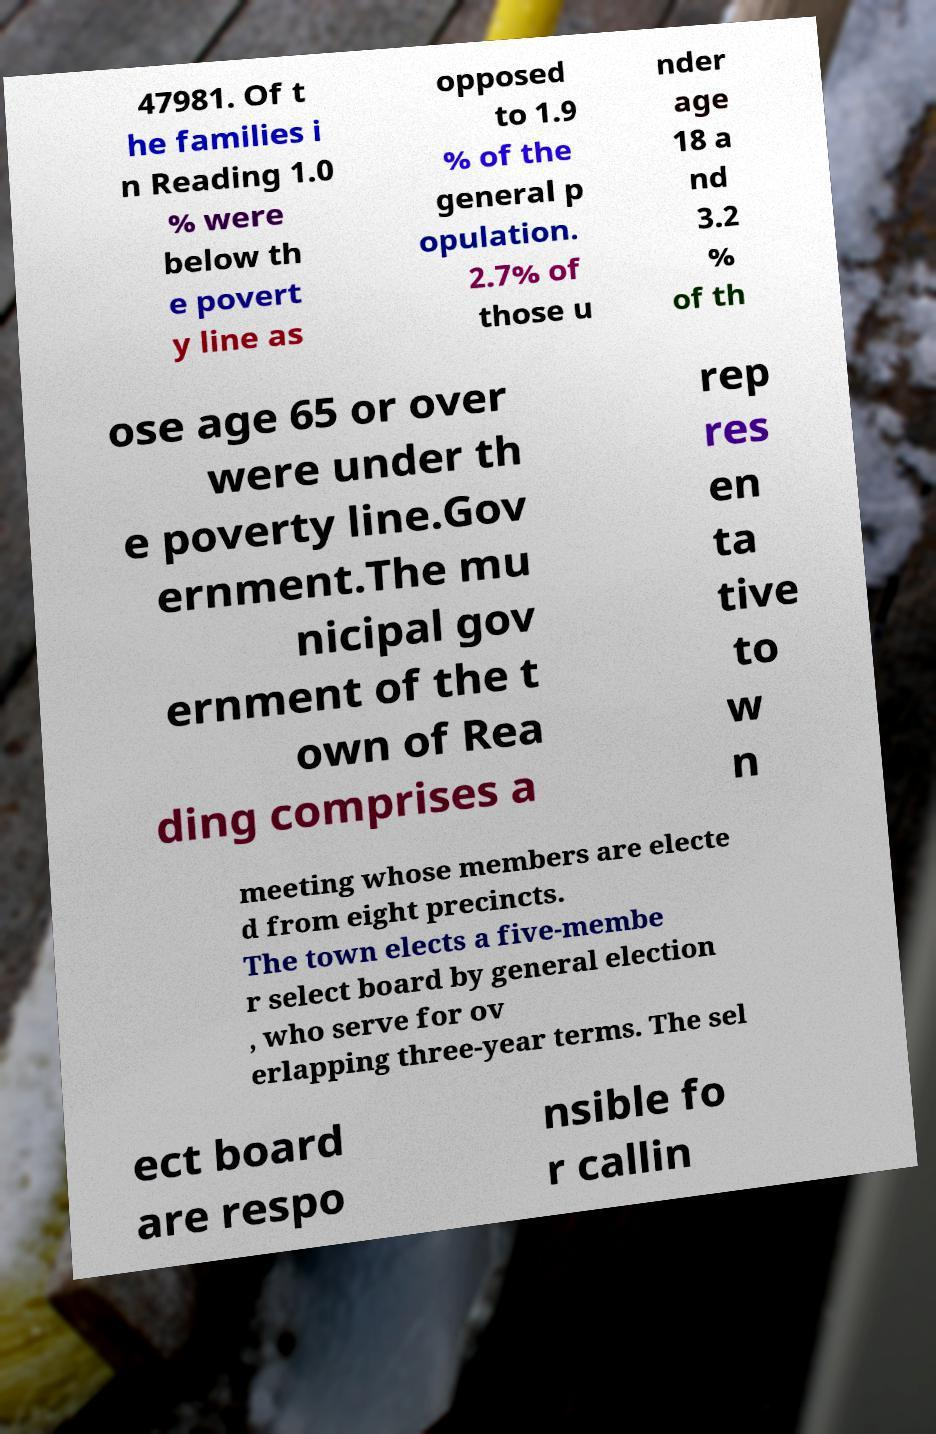What messages or text are displayed in this image? I need them in a readable, typed format. 47981. Of t he families i n Reading 1.0 % were below th e povert y line as opposed to 1.9 % of the general p opulation. 2.7% of those u nder age 18 a nd 3.2 % of th ose age 65 or over were under th e poverty line.Gov ernment.The mu nicipal gov ernment of the t own of Rea ding comprises a rep res en ta tive to w n meeting whose members are electe d from eight precincts. The town elects a five-membe r select board by general election , who serve for ov erlapping three-year terms. The sel ect board are respo nsible fo r callin 